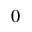<formula> <loc_0><loc_0><loc_500><loc_500>0</formula> 